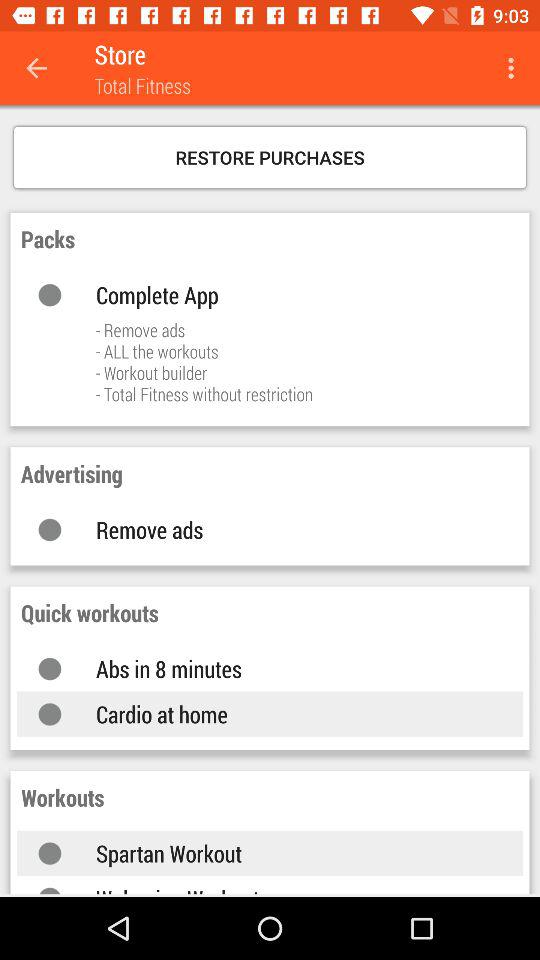What is the information in "Packs"? The information in "Packs" is "Complete App", "Remove ads", "ALL the workouts", "Workout builder" and "Total Fitness without restriction". 